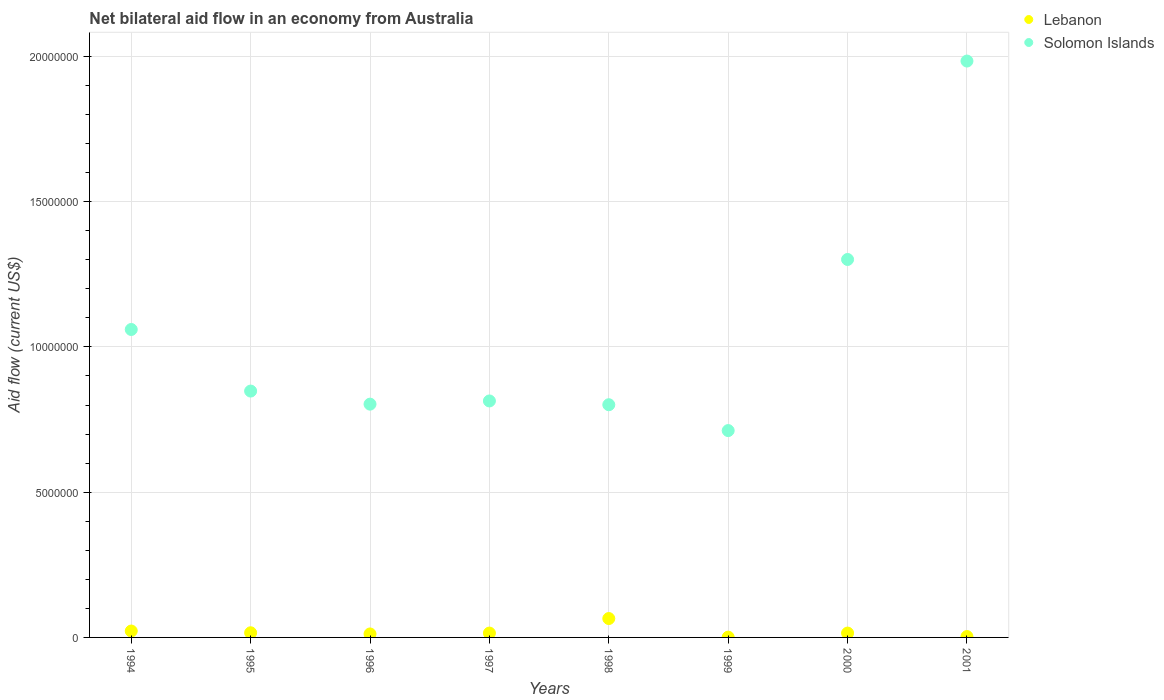What is the net bilateral aid flow in Lebanon in 2001?
Ensure brevity in your answer.  3.00e+04. Across all years, what is the maximum net bilateral aid flow in Lebanon?
Keep it short and to the point. 6.50e+05. In which year was the net bilateral aid flow in Lebanon minimum?
Offer a terse response. 1999. What is the total net bilateral aid flow in Solomon Islands in the graph?
Your answer should be compact. 8.32e+07. What is the difference between the net bilateral aid flow in Lebanon in 1997 and that in 2001?
Ensure brevity in your answer.  1.20e+05. What is the difference between the net bilateral aid flow in Lebanon in 1997 and the net bilateral aid flow in Solomon Islands in 2000?
Your response must be concise. -1.29e+07. What is the average net bilateral aid flow in Lebanon per year?
Your answer should be compact. 1.86e+05. In the year 2000, what is the difference between the net bilateral aid flow in Lebanon and net bilateral aid flow in Solomon Islands?
Your answer should be very brief. -1.29e+07. In how many years, is the net bilateral aid flow in Lebanon greater than 4000000 US$?
Offer a terse response. 0. What is the ratio of the net bilateral aid flow in Lebanon in 1995 to that in 2001?
Your answer should be very brief. 5.33. What is the difference between the highest and the lowest net bilateral aid flow in Solomon Islands?
Make the answer very short. 1.27e+07. How many years are there in the graph?
Provide a short and direct response. 8. What is the difference between two consecutive major ticks on the Y-axis?
Offer a terse response. 5.00e+06. Are the values on the major ticks of Y-axis written in scientific E-notation?
Give a very brief answer. No. Does the graph contain grids?
Make the answer very short. Yes. How are the legend labels stacked?
Provide a succinct answer. Vertical. What is the title of the graph?
Keep it short and to the point. Net bilateral aid flow in an economy from Australia. Does "Fragile and conflict affected situations" appear as one of the legend labels in the graph?
Provide a succinct answer. No. What is the label or title of the X-axis?
Offer a terse response. Years. What is the label or title of the Y-axis?
Give a very brief answer. Aid flow (current US$). What is the Aid flow (current US$) of Lebanon in 1994?
Ensure brevity in your answer.  2.20e+05. What is the Aid flow (current US$) in Solomon Islands in 1994?
Your answer should be compact. 1.06e+07. What is the Aid flow (current US$) of Lebanon in 1995?
Your response must be concise. 1.60e+05. What is the Aid flow (current US$) in Solomon Islands in 1995?
Your answer should be very brief. 8.48e+06. What is the Aid flow (current US$) of Lebanon in 1996?
Your answer should be very brief. 1.20e+05. What is the Aid flow (current US$) in Solomon Islands in 1996?
Your answer should be compact. 8.03e+06. What is the Aid flow (current US$) in Solomon Islands in 1997?
Keep it short and to the point. 8.14e+06. What is the Aid flow (current US$) of Lebanon in 1998?
Make the answer very short. 6.50e+05. What is the Aid flow (current US$) of Solomon Islands in 1998?
Make the answer very short. 8.01e+06. What is the Aid flow (current US$) in Lebanon in 1999?
Provide a short and direct response. 10000. What is the Aid flow (current US$) of Solomon Islands in 1999?
Provide a succinct answer. 7.12e+06. What is the Aid flow (current US$) of Lebanon in 2000?
Keep it short and to the point. 1.50e+05. What is the Aid flow (current US$) in Solomon Islands in 2000?
Provide a succinct answer. 1.30e+07. What is the Aid flow (current US$) of Lebanon in 2001?
Make the answer very short. 3.00e+04. What is the Aid flow (current US$) of Solomon Islands in 2001?
Give a very brief answer. 1.98e+07. Across all years, what is the maximum Aid flow (current US$) in Lebanon?
Make the answer very short. 6.50e+05. Across all years, what is the maximum Aid flow (current US$) in Solomon Islands?
Your answer should be compact. 1.98e+07. Across all years, what is the minimum Aid flow (current US$) of Lebanon?
Your response must be concise. 10000. Across all years, what is the minimum Aid flow (current US$) in Solomon Islands?
Offer a terse response. 7.12e+06. What is the total Aid flow (current US$) in Lebanon in the graph?
Offer a very short reply. 1.49e+06. What is the total Aid flow (current US$) in Solomon Islands in the graph?
Ensure brevity in your answer.  8.32e+07. What is the difference between the Aid flow (current US$) of Solomon Islands in 1994 and that in 1995?
Provide a short and direct response. 2.12e+06. What is the difference between the Aid flow (current US$) in Lebanon in 1994 and that in 1996?
Offer a very short reply. 1.00e+05. What is the difference between the Aid flow (current US$) of Solomon Islands in 1994 and that in 1996?
Keep it short and to the point. 2.57e+06. What is the difference between the Aid flow (current US$) of Solomon Islands in 1994 and that in 1997?
Your answer should be very brief. 2.46e+06. What is the difference between the Aid flow (current US$) of Lebanon in 1994 and that in 1998?
Offer a very short reply. -4.30e+05. What is the difference between the Aid flow (current US$) of Solomon Islands in 1994 and that in 1998?
Provide a succinct answer. 2.59e+06. What is the difference between the Aid flow (current US$) of Lebanon in 1994 and that in 1999?
Keep it short and to the point. 2.10e+05. What is the difference between the Aid flow (current US$) of Solomon Islands in 1994 and that in 1999?
Your answer should be compact. 3.48e+06. What is the difference between the Aid flow (current US$) of Lebanon in 1994 and that in 2000?
Provide a succinct answer. 7.00e+04. What is the difference between the Aid flow (current US$) of Solomon Islands in 1994 and that in 2000?
Your answer should be compact. -2.41e+06. What is the difference between the Aid flow (current US$) in Solomon Islands in 1994 and that in 2001?
Ensure brevity in your answer.  -9.24e+06. What is the difference between the Aid flow (current US$) in Solomon Islands in 1995 and that in 1996?
Offer a very short reply. 4.50e+05. What is the difference between the Aid flow (current US$) in Lebanon in 1995 and that in 1997?
Provide a succinct answer. 10000. What is the difference between the Aid flow (current US$) in Solomon Islands in 1995 and that in 1997?
Give a very brief answer. 3.40e+05. What is the difference between the Aid flow (current US$) in Lebanon in 1995 and that in 1998?
Make the answer very short. -4.90e+05. What is the difference between the Aid flow (current US$) of Solomon Islands in 1995 and that in 1998?
Make the answer very short. 4.70e+05. What is the difference between the Aid flow (current US$) in Lebanon in 1995 and that in 1999?
Keep it short and to the point. 1.50e+05. What is the difference between the Aid flow (current US$) of Solomon Islands in 1995 and that in 1999?
Keep it short and to the point. 1.36e+06. What is the difference between the Aid flow (current US$) in Solomon Islands in 1995 and that in 2000?
Offer a very short reply. -4.53e+06. What is the difference between the Aid flow (current US$) of Lebanon in 1995 and that in 2001?
Make the answer very short. 1.30e+05. What is the difference between the Aid flow (current US$) in Solomon Islands in 1995 and that in 2001?
Keep it short and to the point. -1.14e+07. What is the difference between the Aid flow (current US$) in Lebanon in 1996 and that in 1997?
Provide a succinct answer. -3.00e+04. What is the difference between the Aid flow (current US$) in Solomon Islands in 1996 and that in 1997?
Your response must be concise. -1.10e+05. What is the difference between the Aid flow (current US$) in Lebanon in 1996 and that in 1998?
Your response must be concise. -5.30e+05. What is the difference between the Aid flow (current US$) of Solomon Islands in 1996 and that in 1999?
Your response must be concise. 9.10e+05. What is the difference between the Aid flow (current US$) in Solomon Islands in 1996 and that in 2000?
Provide a succinct answer. -4.98e+06. What is the difference between the Aid flow (current US$) in Lebanon in 1996 and that in 2001?
Give a very brief answer. 9.00e+04. What is the difference between the Aid flow (current US$) in Solomon Islands in 1996 and that in 2001?
Your response must be concise. -1.18e+07. What is the difference between the Aid flow (current US$) in Lebanon in 1997 and that in 1998?
Make the answer very short. -5.00e+05. What is the difference between the Aid flow (current US$) of Solomon Islands in 1997 and that in 1999?
Offer a terse response. 1.02e+06. What is the difference between the Aid flow (current US$) of Solomon Islands in 1997 and that in 2000?
Make the answer very short. -4.87e+06. What is the difference between the Aid flow (current US$) in Solomon Islands in 1997 and that in 2001?
Ensure brevity in your answer.  -1.17e+07. What is the difference between the Aid flow (current US$) in Lebanon in 1998 and that in 1999?
Your answer should be compact. 6.40e+05. What is the difference between the Aid flow (current US$) in Solomon Islands in 1998 and that in 1999?
Offer a terse response. 8.90e+05. What is the difference between the Aid flow (current US$) of Solomon Islands in 1998 and that in 2000?
Keep it short and to the point. -5.00e+06. What is the difference between the Aid flow (current US$) in Lebanon in 1998 and that in 2001?
Your response must be concise. 6.20e+05. What is the difference between the Aid flow (current US$) of Solomon Islands in 1998 and that in 2001?
Your answer should be compact. -1.18e+07. What is the difference between the Aid flow (current US$) of Lebanon in 1999 and that in 2000?
Ensure brevity in your answer.  -1.40e+05. What is the difference between the Aid flow (current US$) in Solomon Islands in 1999 and that in 2000?
Your answer should be very brief. -5.89e+06. What is the difference between the Aid flow (current US$) of Solomon Islands in 1999 and that in 2001?
Offer a terse response. -1.27e+07. What is the difference between the Aid flow (current US$) in Solomon Islands in 2000 and that in 2001?
Provide a succinct answer. -6.83e+06. What is the difference between the Aid flow (current US$) of Lebanon in 1994 and the Aid flow (current US$) of Solomon Islands in 1995?
Your response must be concise. -8.26e+06. What is the difference between the Aid flow (current US$) of Lebanon in 1994 and the Aid flow (current US$) of Solomon Islands in 1996?
Offer a terse response. -7.81e+06. What is the difference between the Aid flow (current US$) of Lebanon in 1994 and the Aid flow (current US$) of Solomon Islands in 1997?
Keep it short and to the point. -7.92e+06. What is the difference between the Aid flow (current US$) in Lebanon in 1994 and the Aid flow (current US$) in Solomon Islands in 1998?
Offer a terse response. -7.79e+06. What is the difference between the Aid flow (current US$) of Lebanon in 1994 and the Aid flow (current US$) of Solomon Islands in 1999?
Your answer should be very brief. -6.90e+06. What is the difference between the Aid flow (current US$) in Lebanon in 1994 and the Aid flow (current US$) in Solomon Islands in 2000?
Keep it short and to the point. -1.28e+07. What is the difference between the Aid flow (current US$) in Lebanon in 1994 and the Aid flow (current US$) in Solomon Islands in 2001?
Offer a terse response. -1.96e+07. What is the difference between the Aid flow (current US$) of Lebanon in 1995 and the Aid flow (current US$) of Solomon Islands in 1996?
Your answer should be very brief. -7.87e+06. What is the difference between the Aid flow (current US$) in Lebanon in 1995 and the Aid flow (current US$) in Solomon Islands in 1997?
Provide a short and direct response. -7.98e+06. What is the difference between the Aid flow (current US$) in Lebanon in 1995 and the Aid flow (current US$) in Solomon Islands in 1998?
Offer a terse response. -7.85e+06. What is the difference between the Aid flow (current US$) of Lebanon in 1995 and the Aid flow (current US$) of Solomon Islands in 1999?
Your response must be concise. -6.96e+06. What is the difference between the Aid flow (current US$) in Lebanon in 1995 and the Aid flow (current US$) in Solomon Islands in 2000?
Your answer should be compact. -1.28e+07. What is the difference between the Aid flow (current US$) in Lebanon in 1995 and the Aid flow (current US$) in Solomon Islands in 2001?
Your answer should be compact. -1.97e+07. What is the difference between the Aid flow (current US$) in Lebanon in 1996 and the Aid flow (current US$) in Solomon Islands in 1997?
Offer a terse response. -8.02e+06. What is the difference between the Aid flow (current US$) in Lebanon in 1996 and the Aid flow (current US$) in Solomon Islands in 1998?
Your answer should be very brief. -7.89e+06. What is the difference between the Aid flow (current US$) of Lebanon in 1996 and the Aid flow (current US$) of Solomon Islands in 1999?
Offer a terse response. -7.00e+06. What is the difference between the Aid flow (current US$) in Lebanon in 1996 and the Aid flow (current US$) in Solomon Islands in 2000?
Keep it short and to the point. -1.29e+07. What is the difference between the Aid flow (current US$) of Lebanon in 1996 and the Aid flow (current US$) of Solomon Islands in 2001?
Make the answer very short. -1.97e+07. What is the difference between the Aid flow (current US$) in Lebanon in 1997 and the Aid flow (current US$) in Solomon Islands in 1998?
Make the answer very short. -7.86e+06. What is the difference between the Aid flow (current US$) in Lebanon in 1997 and the Aid flow (current US$) in Solomon Islands in 1999?
Your answer should be very brief. -6.97e+06. What is the difference between the Aid flow (current US$) of Lebanon in 1997 and the Aid flow (current US$) of Solomon Islands in 2000?
Your answer should be compact. -1.29e+07. What is the difference between the Aid flow (current US$) of Lebanon in 1997 and the Aid flow (current US$) of Solomon Islands in 2001?
Give a very brief answer. -1.97e+07. What is the difference between the Aid flow (current US$) in Lebanon in 1998 and the Aid flow (current US$) in Solomon Islands in 1999?
Your answer should be compact. -6.47e+06. What is the difference between the Aid flow (current US$) of Lebanon in 1998 and the Aid flow (current US$) of Solomon Islands in 2000?
Ensure brevity in your answer.  -1.24e+07. What is the difference between the Aid flow (current US$) in Lebanon in 1998 and the Aid flow (current US$) in Solomon Islands in 2001?
Provide a short and direct response. -1.92e+07. What is the difference between the Aid flow (current US$) of Lebanon in 1999 and the Aid flow (current US$) of Solomon Islands in 2000?
Your response must be concise. -1.30e+07. What is the difference between the Aid flow (current US$) of Lebanon in 1999 and the Aid flow (current US$) of Solomon Islands in 2001?
Make the answer very short. -1.98e+07. What is the difference between the Aid flow (current US$) of Lebanon in 2000 and the Aid flow (current US$) of Solomon Islands in 2001?
Offer a terse response. -1.97e+07. What is the average Aid flow (current US$) of Lebanon per year?
Keep it short and to the point. 1.86e+05. What is the average Aid flow (current US$) of Solomon Islands per year?
Offer a terse response. 1.04e+07. In the year 1994, what is the difference between the Aid flow (current US$) of Lebanon and Aid flow (current US$) of Solomon Islands?
Offer a terse response. -1.04e+07. In the year 1995, what is the difference between the Aid flow (current US$) of Lebanon and Aid flow (current US$) of Solomon Islands?
Your answer should be compact. -8.32e+06. In the year 1996, what is the difference between the Aid flow (current US$) in Lebanon and Aid flow (current US$) in Solomon Islands?
Offer a very short reply. -7.91e+06. In the year 1997, what is the difference between the Aid flow (current US$) in Lebanon and Aid flow (current US$) in Solomon Islands?
Provide a succinct answer. -7.99e+06. In the year 1998, what is the difference between the Aid flow (current US$) in Lebanon and Aid flow (current US$) in Solomon Islands?
Offer a terse response. -7.36e+06. In the year 1999, what is the difference between the Aid flow (current US$) of Lebanon and Aid flow (current US$) of Solomon Islands?
Provide a succinct answer. -7.11e+06. In the year 2000, what is the difference between the Aid flow (current US$) in Lebanon and Aid flow (current US$) in Solomon Islands?
Offer a very short reply. -1.29e+07. In the year 2001, what is the difference between the Aid flow (current US$) in Lebanon and Aid flow (current US$) in Solomon Islands?
Give a very brief answer. -1.98e+07. What is the ratio of the Aid flow (current US$) of Lebanon in 1994 to that in 1995?
Your answer should be compact. 1.38. What is the ratio of the Aid flow (current US$) of Lebanon in 1994 to that in 1996?
Ensure brevity in your answer.  1.83. What is the ratio of the Aid flow (current US$) in Solomon Islands in 1994 to that in 1996?
Your answer should be compact. 1.32. What is the ratio of the Aid flow (current US$) in Lebanon in 1994 to that in 1997?
Offer a very short reply. 1.47. What is the ratio of the Aid flow (current US$) in Solomon Islands in 1994 to that in 1997?
Provide a succinct answer. 1.3. What is the ratio of the Aid flow (current US$) of Lebanon in 1994 to that in 1998?
Provide a short and direct response. 0.34. What is the ratio of the Aid flow (current US$) of Solomon Islands in 1994 to that in 1998?
Your response must be concise. 1.32. What is the ratio of the Aid flow (current US$) of Lebanon in 1994 to that in 1999?
Provide a short and direct response. 22. What is the ratio of the Aid flow (current US$) in Solomon Islands in 1994 to that in 1999?
Provide a succinct answer. 1.49. What is the ratio of the Aid flow (current US$) of Lebanon in 1994 to that in 2000?
Your answer should be very brief. 1.47. What is the ratio of the Aid flow (current US$) of Solomon Islands in 1994 to that in 2000?
Keep it short and to the point. 0.81. What is the ratio of the Aid flow (current US$) of Lebanon in 1994 to that in 2001?
Make the answer very short. 7.33. What is the ratio of the Aid flow (current US$) in Solomon Islands in 1994 to that in 2001?
Offer a terse response. 0.53. What is the ratio of the Aid flow (current US$) of Lebanon in 1995 to that in 1996?
Make the answer very short. 1.33. What is the ratio of the Aid flow (current US$) in Solomon Islands in 1995 to that in 1996?
Your response must be concise. 1.06. What is the ratio of the Aid flow (current US$) of Lebanon in 1995 to that in 1997?
Make the answer very short. 1.07. What is the ratio of the Aid flow (current US$) in Solomon Islands in 1995 to that in 1997?
Keep it short and to the point. 1.04. What is the ratio of the Aid flow (current US$) of Lebanon in 1995 to that in 1998?
Provide a short and direct response. 0.25. What is the ratio of the Aid flow (current US$) of Solomon Islands in 1995 to that in 1998?
Your answer should be compact. 1.06. What is the ratio of the Aid flow (current US$) of Lebanon in 1995 to that in 1999?
Make the answer very short. 16. What is the ratio of the Aid flow (current US$) in Solomon Islands in 1995 to that in 1999?
Give a very brief answer. 1.19. What is the ratio of the Aid flow (current US$) of Lebanon in 1995 to that in 2000?
Give a very brief answer. 1.07. What is the ratio of the Aid flow (current US$) of Solomon Islands in 1995 to that in 2000?
Provide a short and direct response. 0.65. What is the ratio of the Aid flow (current US$) in Lebanon in 1995 to that in 2001?
Your response must be concise. 5.33. What is the ratio of the Aid flow (current US$) in Solomon Islands in 1995 to that in 2001?
Your response must be concise. 0.43. What is the ratio of the Aid flow (current US$) in Lebanon in 1996 to that in 1997?
Give a very brief answer. 0.8. What is the ratio of the Aid flow (current US$) in Solomon Islands in 1996 to that in 1997?
Offer a terse response. 0.99. What is the ratio of the Aid flow (current US$) of Lebanon in 1996 to that in 1998?
Your answer should be very brief. 0.18. What is the ratio of the Aid flow (current US$) in Solomon Islands in 1996 to that in 1999?
Provide a succinct answer. 1.13. What is the ratio of the Aid flow (current US$) of Lebanon in 1996 to that in 2000?
Ensure brevity in your answer.  0.8. What is the ratio of the Aid flow (current US$) of Solomon Islands in 1996 to that in 2000?
Provide a succinct answer. 0.62. What is the ratio of the Aid flow (current US$) of Lebanon in 1996 to that in 2001?
Your answer should be very brief. 4. What is the ratio of the Aid flow (current US$) in Solomon Islands in 1996 to that in 2001?
Your answer should be very brief. 0.4. What is the ratio of the Aid flow (current US$) of Lebanon in 1997 to that in 1998?
Your answer should be compact. 0.23. What is the ratio of the Aid flow (current US$) in Solomon Islands in 1997 to that in 1998?
Give a very brief answer. 1.02. What is the ratio of the Aid flow (current US$) of Solomon Islands in 1997 to that in 1999?
Provide a short and direct response. 1.14. What is the ratio of the Aid flow (current US$) of Solomon Islands in 1997 to that in 2000?
Your answer should be very brief. 0.63. What is the ratio of the Aid flow (current US$) of Solomon Islands in 1997 to that in 2001?
Your response must be concise. 0.41. What is the ratio of the Aid flow (current US$) of Solomon Islands in 1998 to that in 1999?
Make the answer very short. 1.12. What is the ratio of the Aid flow (current US$) in Lebanon in 1998 to that in 2000?
Your answer should be very brief. 4.33. What is the ratio of the Aid flow (current US$) of Solomon Islands in 1998 to that in 2000?
Your answer should be very brief. 0.62. What is the ratio of the Aid flow (current US$) of Lebanon in 1998 to that in 2001?
Give a very brief answer. 21.67. What is the ratio of the Aid flow (current US$) in Solomon Islands in 1998 to that in 2001?
Offer a terse response. 0.4. What is the ratio of the Aid flow (current US$) in Lebanon in 1999 to that in 2000?
Provide a succinct answer. 0.07. What is the ratio of the Aid flow (current US$) of Solomon Islands in 1999 to that in 2000?
Ensure brevity in your answer.  0.55. What is the ratio of the Aid flow (current US$) in Lebanon in 1999 to that in 2001?
Your response must be concise. 0.33. What is the ratio of the Aid flow (current US$) in Solomon Islands in 1999 to that in 2001?
Your response must be concise. 0.36. What is the ratio of the Aid flow (current US$) of Lebanon in 2000 to that in 2001?
Provide a succinct answer. 5. What is the ratio of the Aid flow (current US$) of Solomon Islands in 2000 to that in 2001?
Ensure brevity in your answer.  0.66. What is the difference between the highest and the second highest Aid flow (current US$) of Lebanon?
Your answer should be very brief. 4.30e+05. What is the difference between the highest and the second highest Aid flow (current US$) of Solomon Islands?
Your response must be concise. 6.83e+06. What is the difference between the highest and the lowest Aid flow (current US$) of Lebanon?
Keep it short and to the point. 6.40e+05. What is the difference between the highest and the lowest Aid flow (current US$) of Solomon Islands?
Offer a terse response. 1.27e+07. 